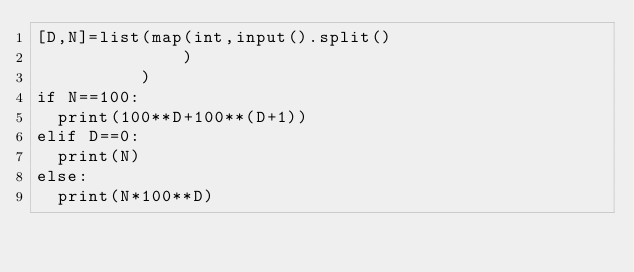<code> <loc_0><loc_0><loc_500><loc_500><_Python_>[D,N]=list(map(int,input().split()
              )
          )
if N==100:
  print(100**D+100**(D+1))
elif D==0:
  print(N)
else:
  print(N*100**D)</code> 